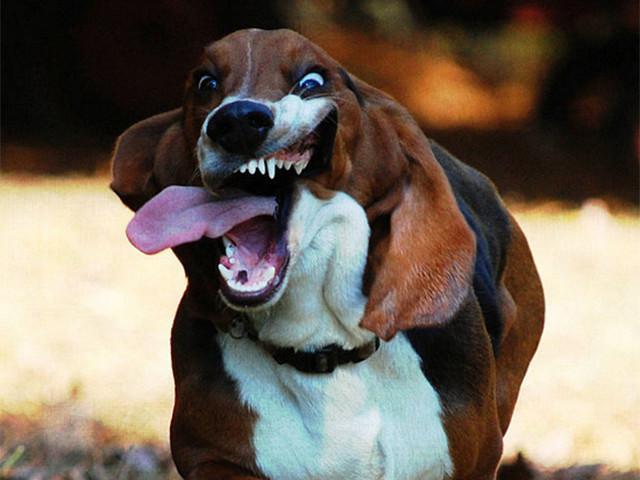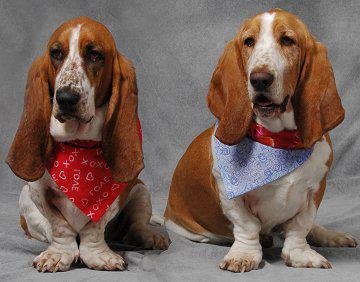The first image is the image on the left, the second image is the image on the right. For the images displayed, is the sentence "An image shows one forward-turned basset hound, which has its mouth open fairly wide." factually correct? Answer yes or no. Yes. The first image is the image on the left, the second image is the image on the right. Evaluate the accuracy of this statement regarding the images: "The mouth of the dog in the image on the left is open.". Is it true? Answer yes or no. Yes. 